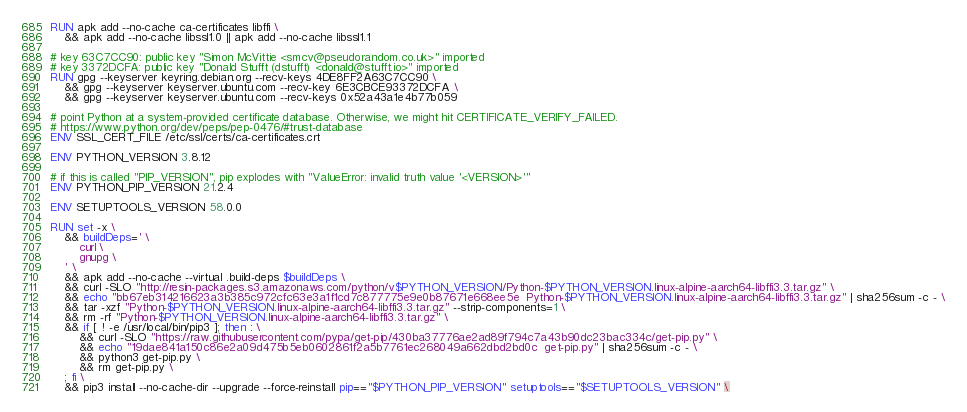Convert code to text. <code><loc_0><loc_0><loc_500><loc_500><_Dockerfile_>RUN apk add --no-cache ca-certificates libffi \
	&& apk add --no-cache libssl1.0 || apk add --no-cache libssl1.1

# key 63C7CC90: public key "Simon McVittie <smcv@pseudorandom.co.uk>" imported
# key 3372DCFA: public key "Donald Stufft (dstufft) <donald@stufft.io>" imported
RUN gpg --keyserver keyring.debian.org --recv-keys 4DE8FF2A63C7CC90 \
	&& gpg --keyserver keyserver.ubuntu.com --recv-key 6E3CBCE93372DCFA \
	&& gpg --keyserver keyserver.ubuntu.com --recv-keys 0x52a43a1e4b77b059

# point Python at a system-provided certificate database. Otherwise, we might hit CERTIFICATE_VERIFY_FAILED.
# https://www.python.org/dev/peps/pep-0476/#trust-database
ENV SSL_CERT_FILE /etc/ssl/certs/ca-certificates.crt

ENV PYTHON_VERSION 3.8.12

# if this is called "PIP_VERSION", pip explodes with "ValueError: invalid truth value '<VERSION>'"
ENV PYTHON_PIP_VERSION 21.2.4

ENV SETUPTOOLS_VERSION 58.0.0

RUN set -x \
	&& buildDeps=' \
		curl \
		gnupg \
	' \
	&& apk add --no-cache --virtual .build-deps $buildDeps \
	&& curl -SLO "http://resin-packages.s3.amazonaws.com/python/v$PYTHON_VERSION/Python-$PYTHON_VERSION.linux-alpine-aarch64-libffi3.3.tar.gz" \
	&& echo "bb67eb314216623a3b385c972cfc63e3a1f1cd7c877775e9e0b87671e668ee5e  Python-$PYTHON_VERSION.linux-alpine-aarch64-libffi3.3.tar.gz" | sha256sum -c - \
	&& tar -xzf "Python-$PYTHON_VERSION.linux-alpine-aarch64-libffi3.3.tar.gz" --strip-components=1 \
	&& rm -rf "Python-$PYTHON_VERSION.linux-alpine-aarch64-libffi3.3.tar.gz" \
	&& if [ ! -e /usr/local/bin/pip3 ]; then : \
		&& curl -SLO "https://raw.githubusercontent.com/pypa/get-pip/430ba37776ae2ad89f794c7a43b90dc23bac334c/get-pip.py" \
		&& echo "19dae841a150c86e2a09d475b5eb0602861f2a5b7761ec268049a662dbd2bd0c  get-pip.py" | sha256sum -c - \
		&& python3 get-pip.py \
		&& rm get-pip.py \
	; fi \
	&& pip3 install --no-cache-dir --upgrade --force-reinstall pip=="$PYTHON_PIP_VERSION" setuptools=="$SETUPTOOLS_VERSION" \</code> 